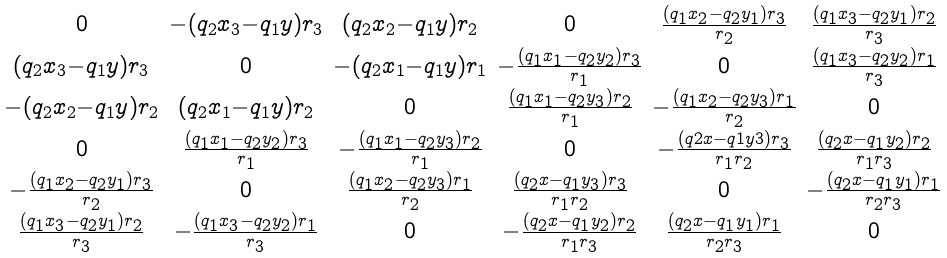<formula> <loc_0><loc_0><loc_500><loc_500>\begin{smallmatrix} 0 & - ( q _ { 2 } x _ { 3 } - q _ { 1 } y ) r _ { 3 } & ( q _ { 2 } x _ { 2 } - q _ { 1 } y ) r _ { 2 } & 0 & \frac { ( q _ { 1 } x _ { 2 } - q _ { 2 } y _ { 1 } ) r _ { 3 } } { r _ { 2 } } & \frac { ( q _ { 1 } x _ { 3 } - q _ { 2 } y _ { 1 } ) r _ { 2 } } { r _ { 3 } } \\ ( q _ { 2 } x _ { 3 } - q _ { 1 } y ) r _ { 3 } & 0 & - ( q _ { 2 } x _ { 1 } - q _ { 1 } y ) r _ { 1 } & - \frac { ( q _ { 1 } x _ { 1 } - q _ { 2 } y _ { 2 } ) r _ { 3 } } { r _ { 1 } } & 0 & \frac { ( q _ { 1 } x _ { 3 } - q _ { 2 } y _ { 2 } ) r _ { 1 } } { r _ { 3 } } \\ - ( q _ { 2 } x _ { 2 } - q _ { 1 } y ) r _ { 2 } & ( q _ { 2 } x _ { 1 } - q _ { 1 } y ) r _ { 2 } & 0 & \frac { ( q _ { 1 } x _ { 1 } - q _ { 2 } y _ { 3 } ) r _ { 2 } } { r _ { 1 } } & - \frac { ( q _ { 1 } x _ { 2 } - q _ { 2 } y _ { 3 } ) r _ { 1 } } { r _ { 2 } } & 0 \\ 0 & \frac { ( q _ { 1 } x _ { 1 } - q _ { 2 } y _ { 2 } ) r _ { 3 } } { r _ { 1 } } & - \frac { ( q _ { 1 } x _ { 1 } - q _ { 2 } y _ { 3 } ) r _ { 2 } } { r _ { 1 } } & 0 & - \frac { ( q 2 x - q 1 y 3 ) r _ { 3 } } { r _ { 1 } r _ { 2 } } & \frac { ( q _ { 2 } x - q _ { 1 } y _ { 2 } ) r _ { 2 } } { r _ { 1 } r _ { 3 } } \\ - \frac { ( q _ { 1 } x _ { 2 } - q _ { 2 } y _ { 1 } ) r _ { 3 } } { r _ { 2 } } & 0 & \frac { ( q _ { 1 } x _ { 2 } - q _ { 2 } y _ { 3 } ) r _ { 1 } } { r _ { 2 } } & \frac { ( q _ { 2 } x - q _ { 1 } y _ { 3 } ) r _ { 3 } } { r _ { 1 } r _ { 2 } } & 0 & - \frac { ( q _ { 2 } x - q _ { 1 } y _ { 1 } ) r _ { 1 } } { r _ { 2 } r _ { 3 } } \\ \frac { ( q _ { 1 } x _ { 3 } - q _ { 2 } y _ { 1 } ) r _ { 2 } } { r _ { 3 } } & - \frac { ( q _ { 1 } x _ { 3 } - q _ { 2 } y _ { 2 } ) r _ { 1 } } { r _ { 3 } } & 0 & - \frac { ( q _ { 2 } x - q _ { 1 } y _ { 2 } ) r _ { 2 } } { r _ { 1 } r _ { 3 } } & \frac { ( q _ { 2 } x - q _ { 1 } y _ { 1 } ) r _ { 1 } } { r _ { 2 } r _ { 3 } } & 0 \\ \end{smallmatrix}</formula> 